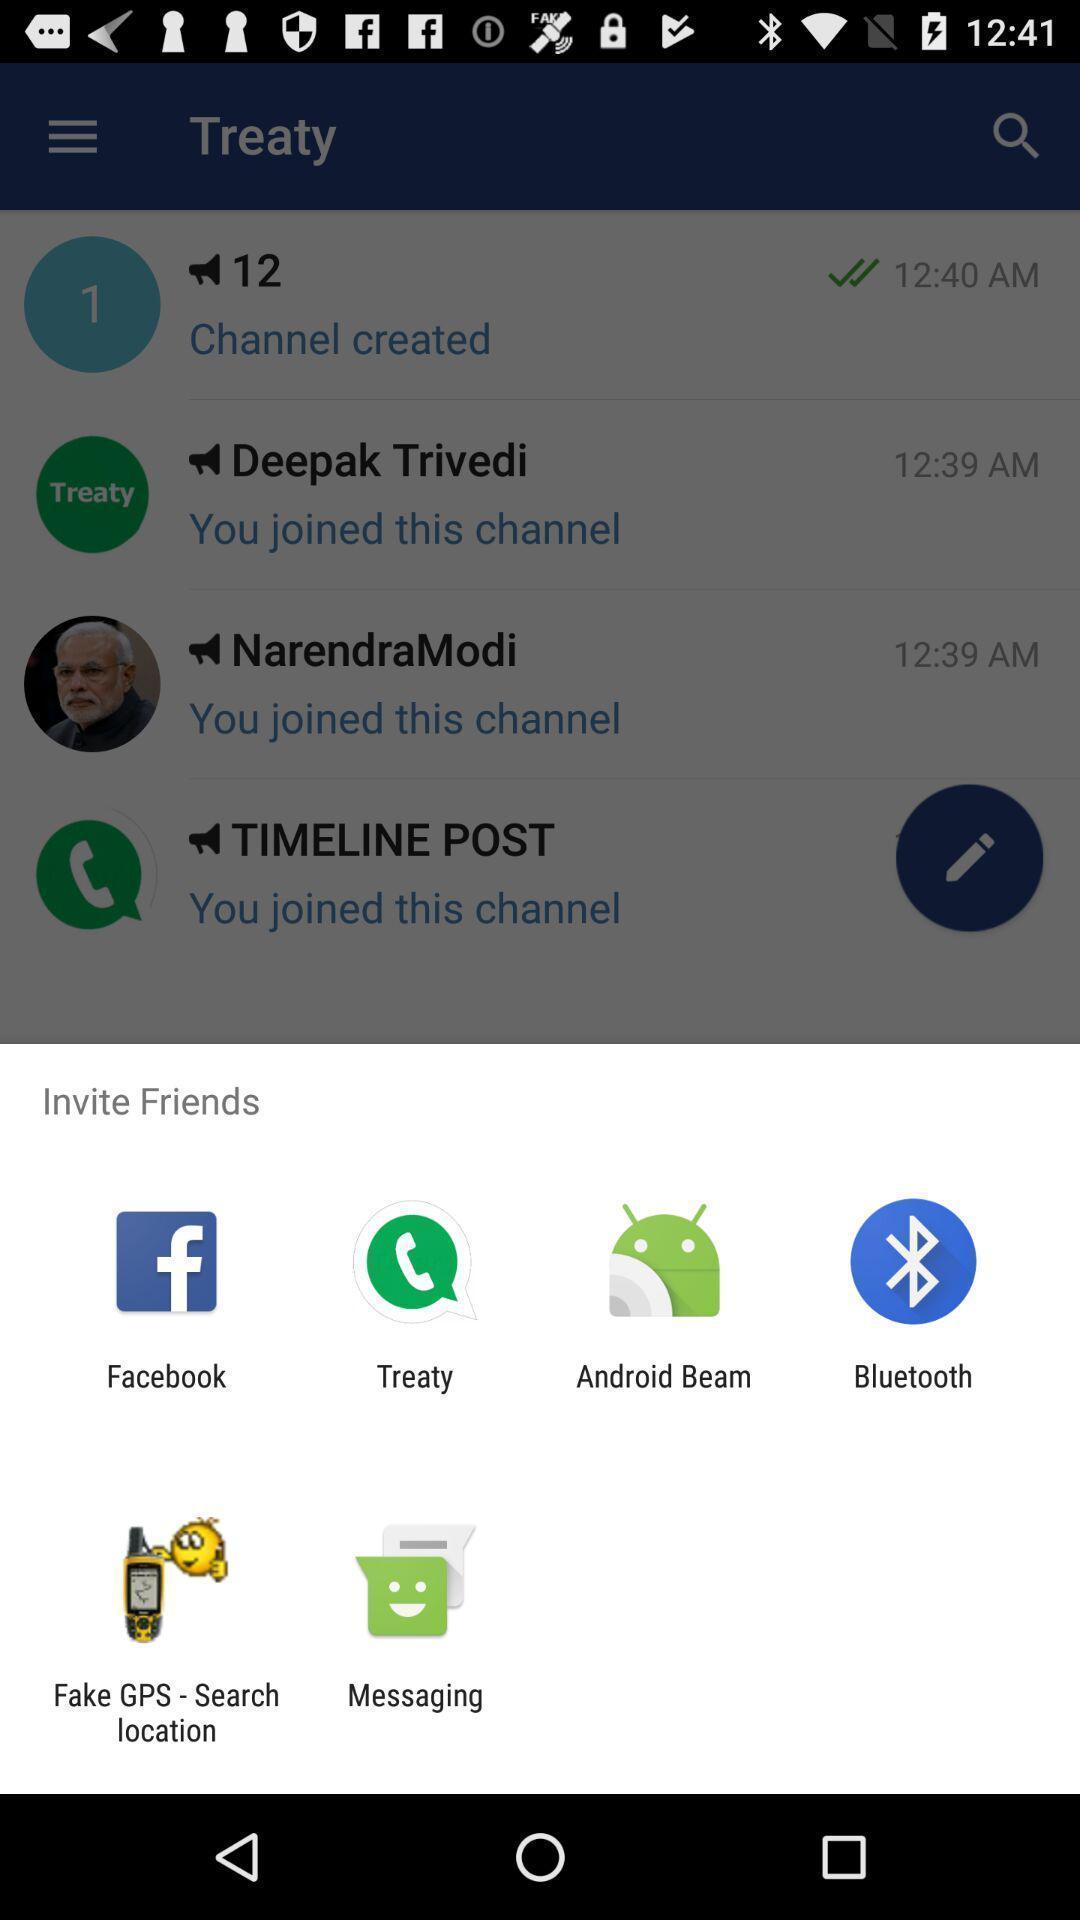What is the overall content of this screenshot? Popup of different applications to invite the friends. 